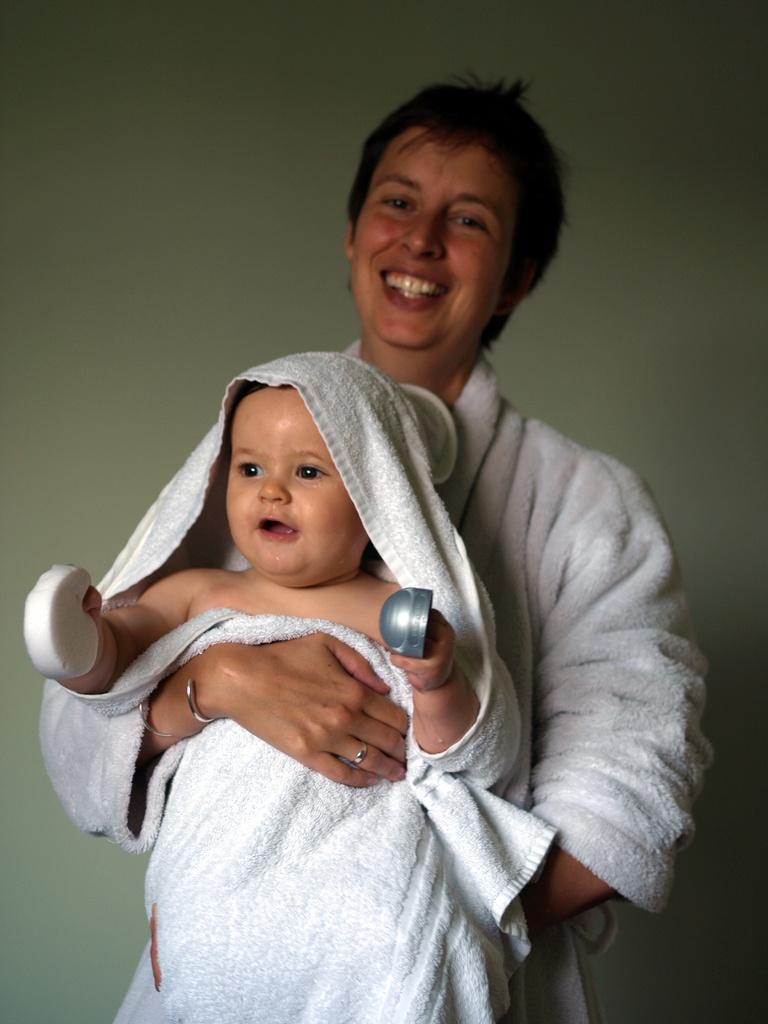What is the person in the image doing? The person is holding a baby in the image. What is the baby doing? The baby is holding some objects. What can be seen in the background of the image? There is a wall visible in the background of the image. What type of pets can be seen singing in the image? There are no pets or singing in the image; it features a person holding a baby and a wall in the background. 